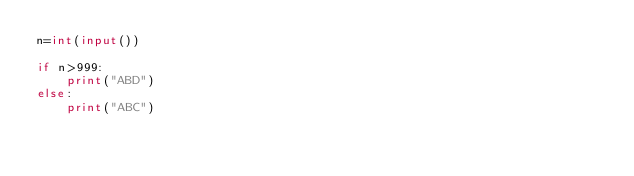<code> <loc_0><loc_0><loc_500><loc_500><_Python_>n=int(input())

if n>999:
    print("ABD")
else:
    print("ABC")</code> 